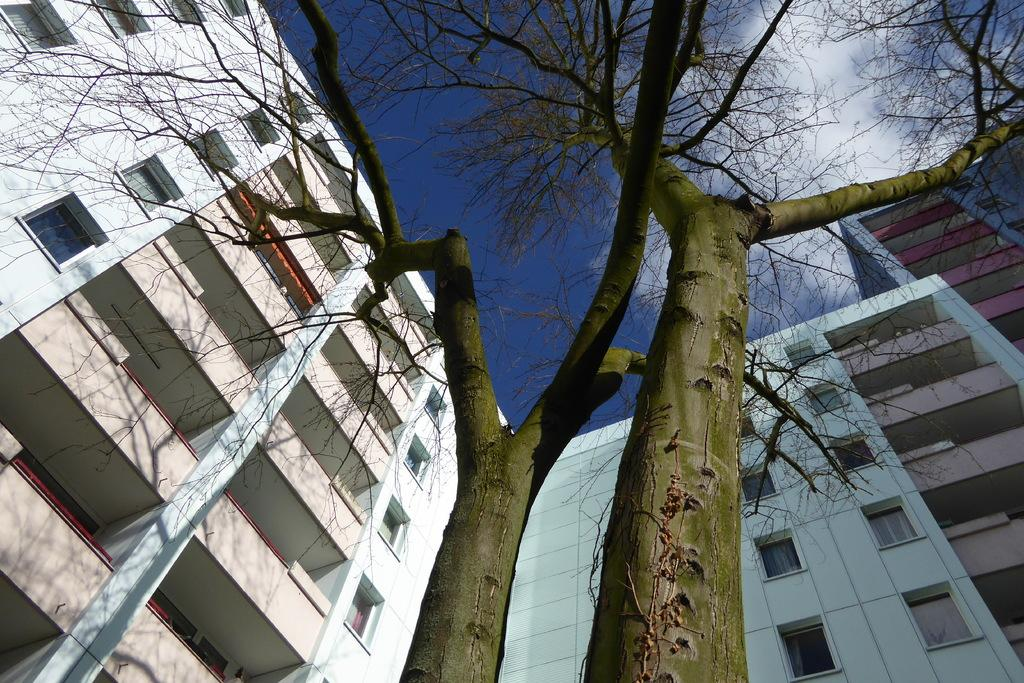What type of structures can be seen in the image? There are buildings in the image. What type of vegetation is present in the image? There are trees in the image. What can be seen in the sky in the image? There are clouds in the image. Where is the waste located in the image? There is no waste present in the image. What type of pest can be seen crawling on the buildings in the image? There are no pests visible in the image. How many knots are tied in the trees in the image? There are no knots present in the image. 